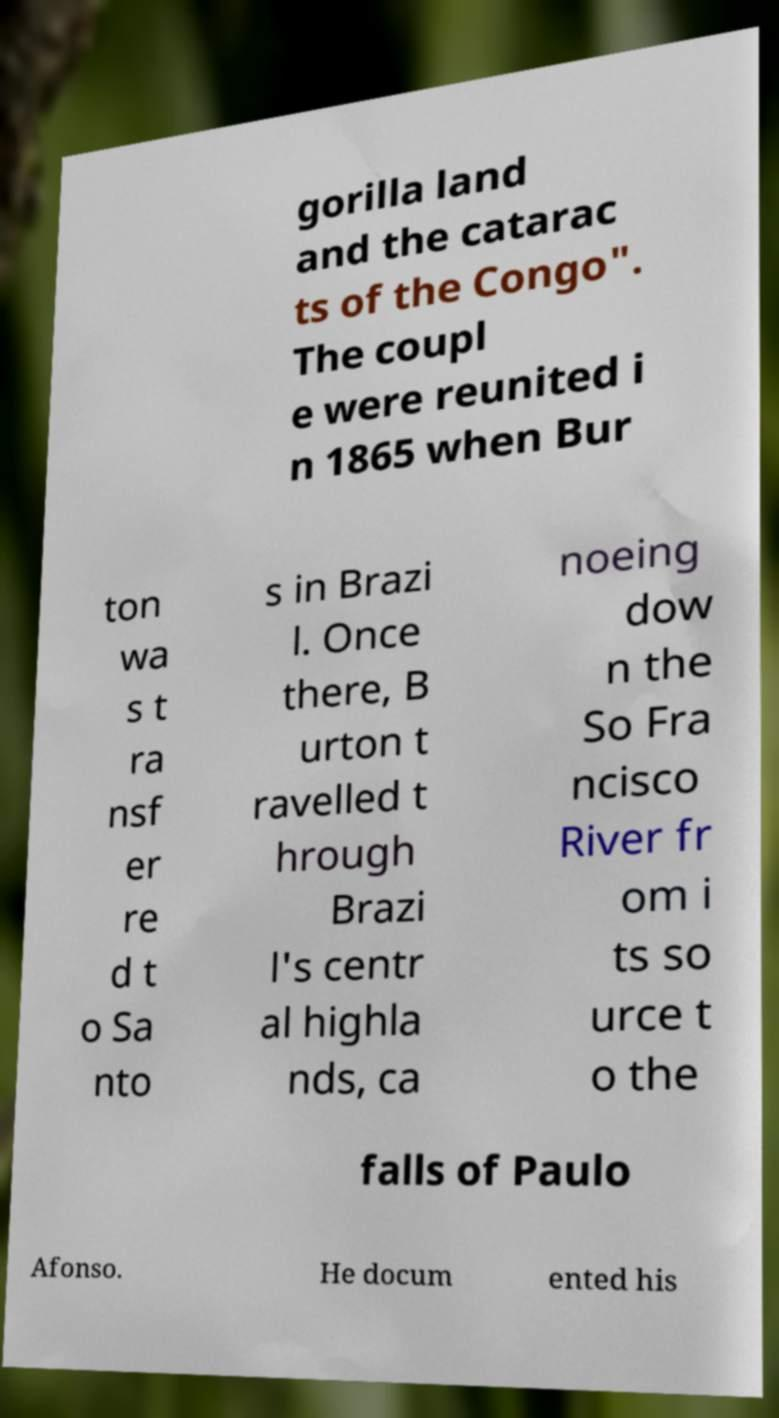Can you read and provide the text displayed in the image?This photo seems to have some interesting text. Can you extract and type it out for me? gorilla land and the catarac ts of the Congo". The coupl e were reunited i n 1865 when Bur ton wa s t ra nsf er re d t o Sa nto s in Brazi l. Once there, B urton t ravelled t hrough Brazi l's centr al highla nds, ca noeing dow n the So Fra ncisco River fr om i ts so urce t o the falls of Paulo Afonso. He docum ented his 